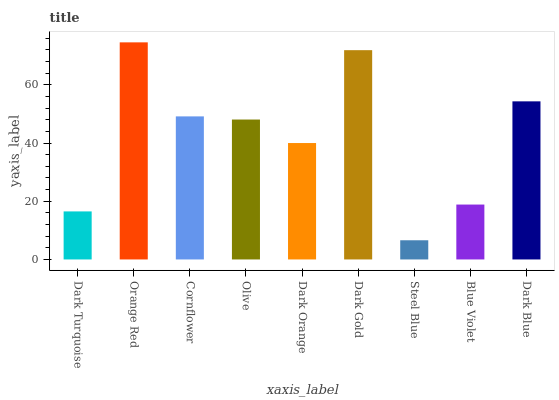Is Steel Blue the minimum?
Answer yes or no. Yes. Is Orange Red the maximum?
Answer yes or no. Yes. Is Cornflower the minimum?
Answer yes or no. No. Is Cornflower the maximum?
Answer yes or no. No. Is Orange Red greater than Cornflower?
Answer yes or no. Yes. Is Cornflower less than Orange Red?
Answer yes or no. Yes. Is Cornflower greater than Orange Red?
Answer yes or no. No. Is Orange Red less than Cornflower?
Answer yes or no. No. Is Olive the high median?
Answer yes or no. Yes. Is Olive the low median?
Answer yes or no. Yes. Is Dark Turquoise the high median?
Answer yes or no. No. Is Blue Violet the low median?
Answer yes or no. No. 